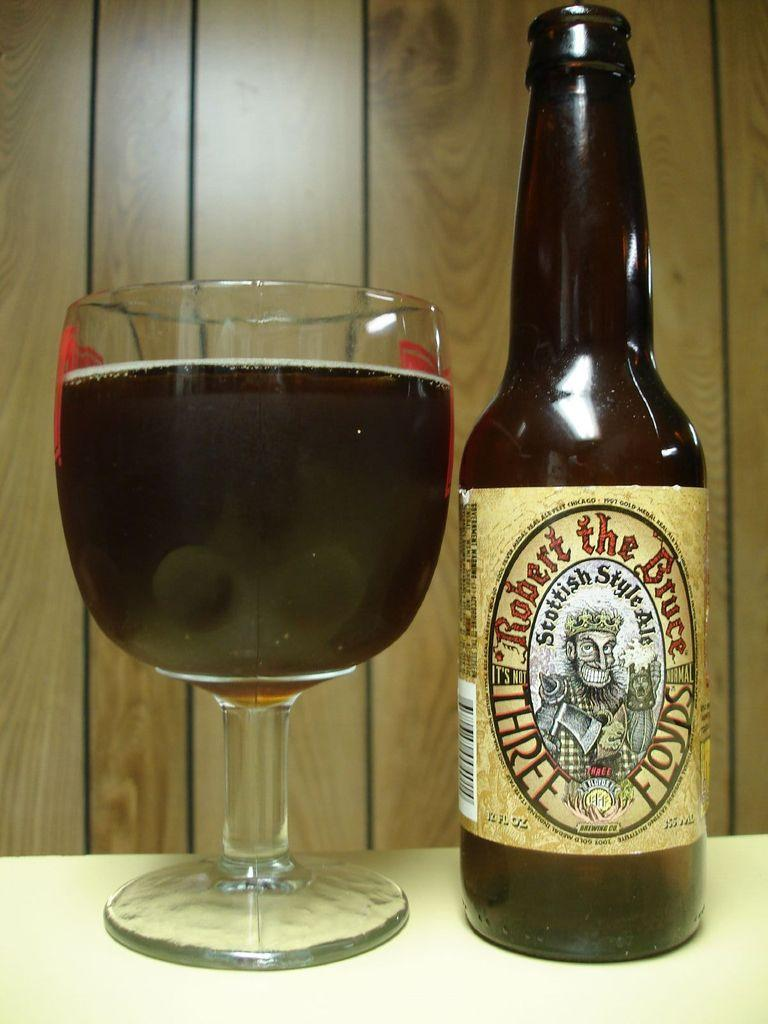<image>
Relay a brief, clear account of the picture shown. A glass of Robert the Bruce Scottish style ale 